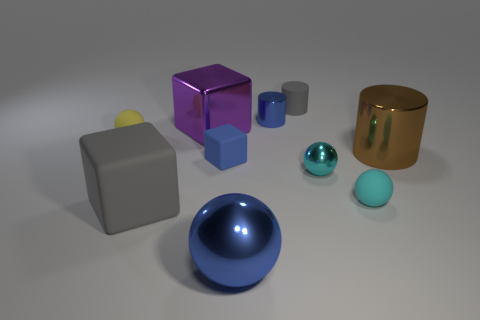Subtract all matte cubes. How many cubes are left? 1 Subtract all purple cubes. How many cubes are left? 2 Subtract all green blocks. How many cyan balls are left? 2 Subtract all blocks. How many objects are left? 7 Subtract 3 balls. How many balls are left? 1 Subtract all large purple metal cubes. Subtract all tiny cyan objects. How many objects are left? 7 Add 8 gray things. How many gray things are left? 10 Add 1 small purple metal blocks. How many small purple metal blocks exist? 1 Subtract 1 blue spheres. How many objects are left? 9 Subtract all brown cylinders. Subtract all cyan balls. How many cylinders are left? 2 